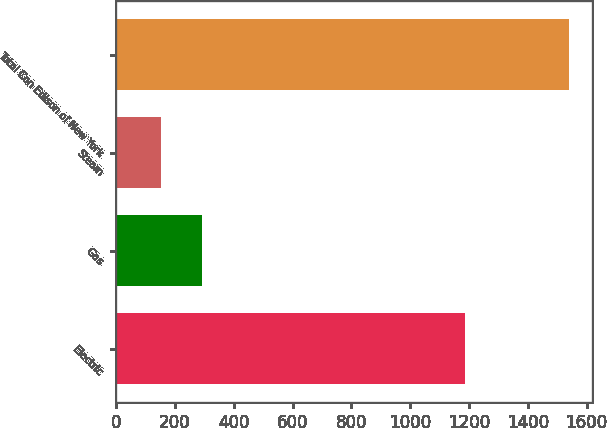Convert chart to OTSL. <chart><loc_0><loc_0><loc_500><loc_500><bar_chart><fcel>Electric<fcel>Gas<fcel>Steam<fcel>Total Con Edison of New York<nl><fcel>1186<fcel>292.7<fcel>154<fcel>1541<nl></chart> 